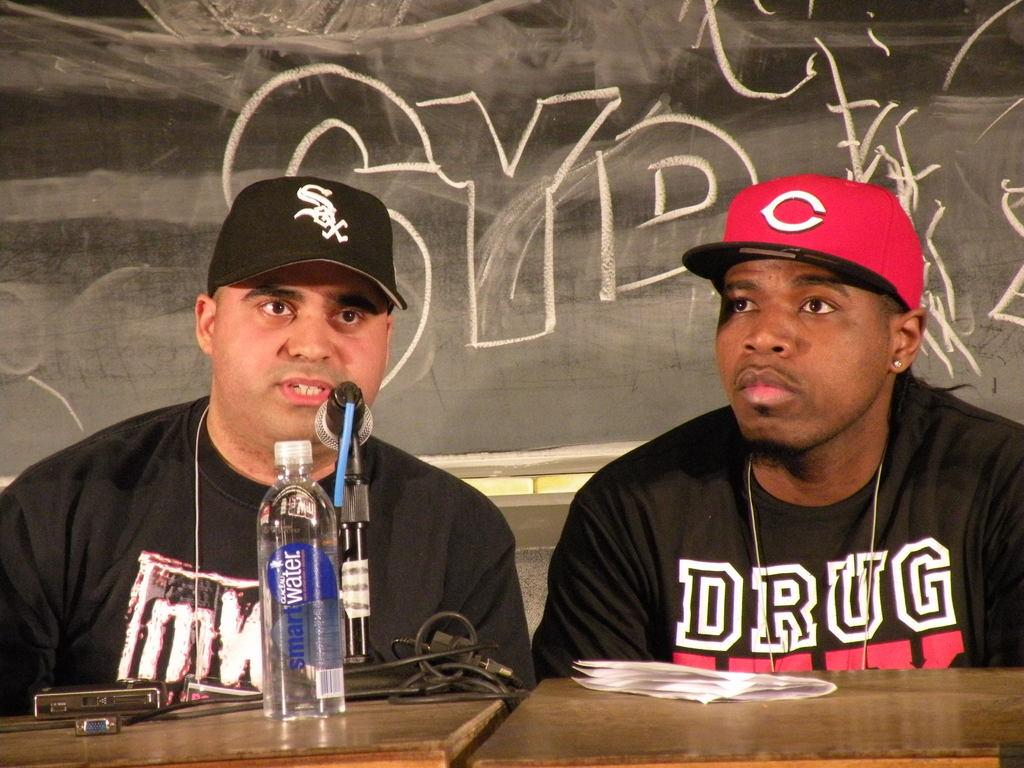<image>
Create a compact narrative representing the image presented. One of the guys speaking has a Smart Water bottle in front of him. 